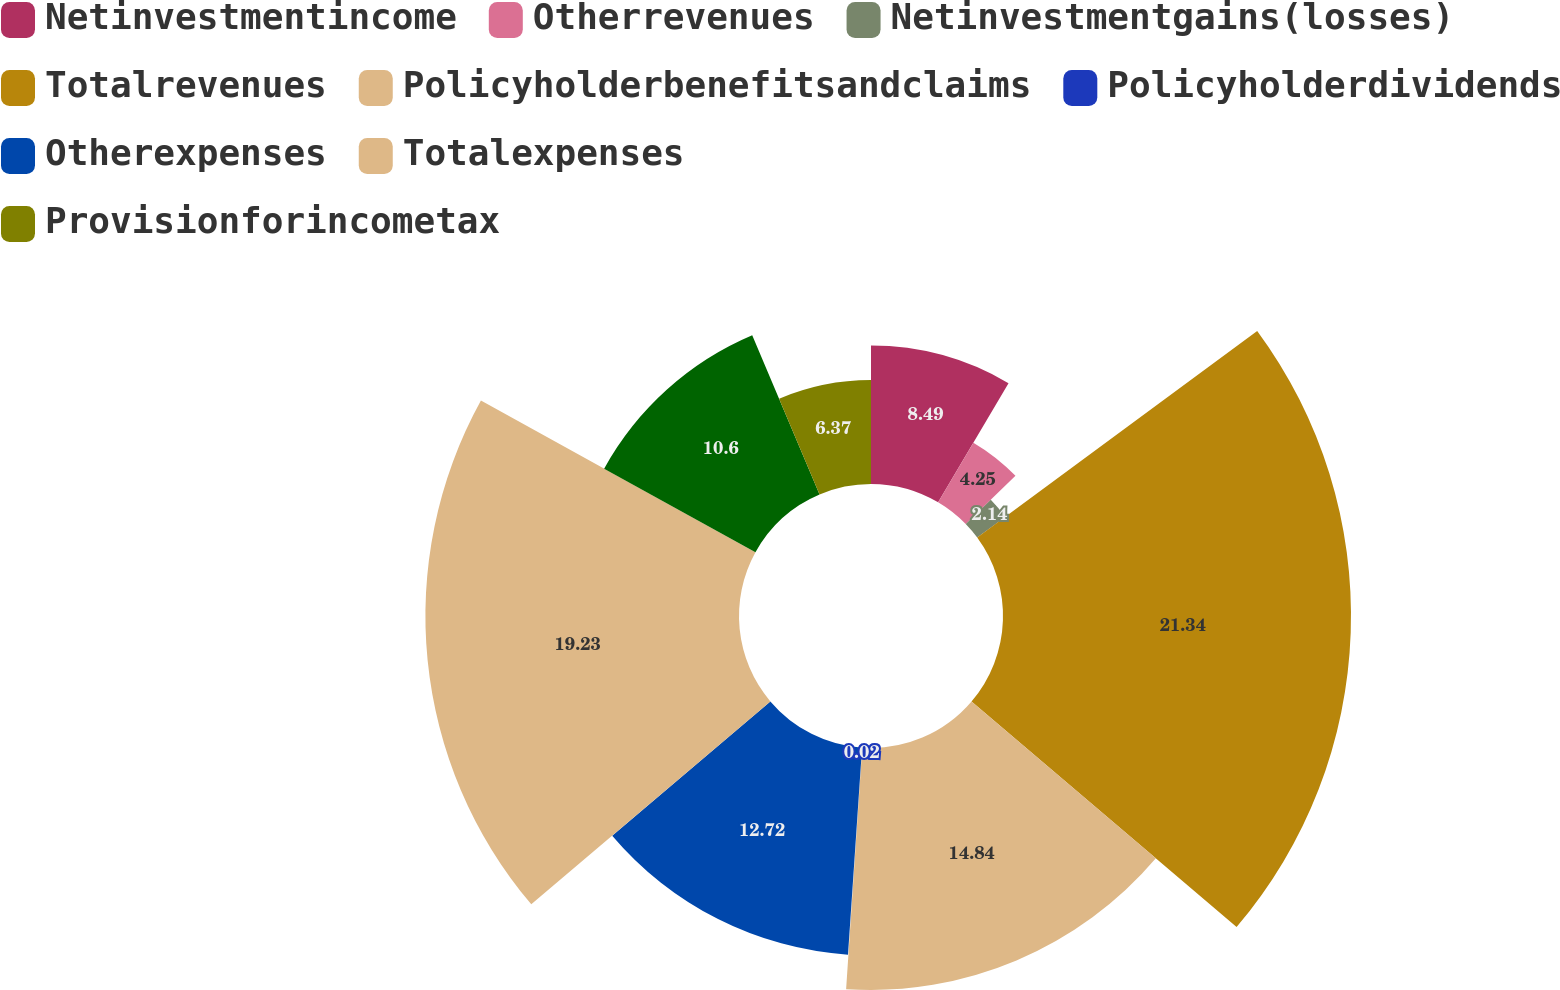Convert chart. <chart><loc_0><loc_0><loc_500><loc_500><pie_chart><fcel>Netinvestmentincome<fcel>Otherrevenues<fcel>Netinvestmentgains(losses)<fcel>Totalrevenues<fcel>Policyholderbenefitsandclaims<fcel>Policyholderdividends<fcel>Otherexpenses<fcel>Totalexpenses<fcel>Unnamed: 8<fcel>Provisionforincometax<nl><fcel>8.49%<fcel>4.25%<fcel>2.14%<fcel>21.34%<fcel>14.84%<fcel>0.02%<fcel>12.72%<fcel>19.23%<fcel>10.6%<fcel>6.37%<nl></chart> 